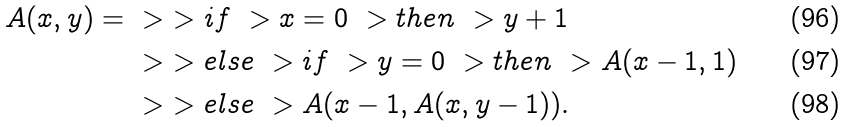Convert formula to latex. <formula><loc_0><loc_0><loc_500><loc_500>A ( x , y ) = & \ > \ > i f \ > x = 0 \ > t h e n \ > y + 1 \\ & \ > \ > e l s e \ > i f \ > y = 0 \ > t h e n \ > A ( x - 1 , 1 ) \\ & \ > \ > e l s e \ > A ( x - 1 , A ( x , y - 1 ) ) .</formula> 